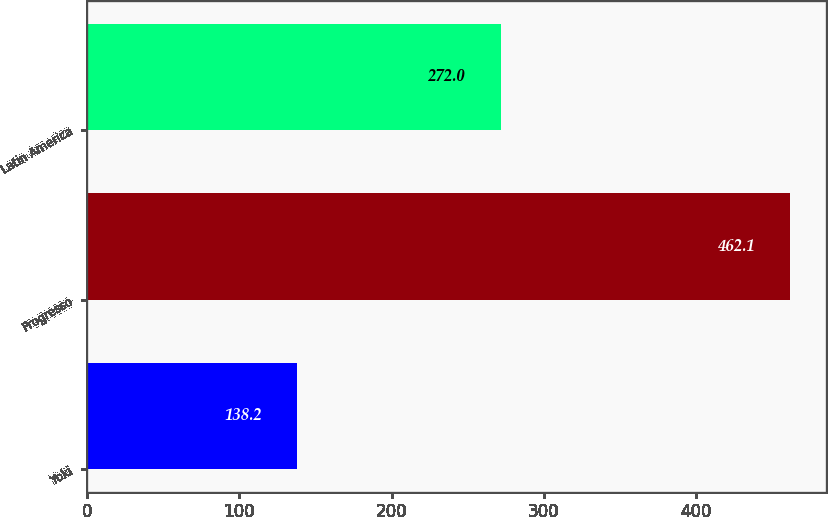<chart> <loc_0><loc_0><loc_500><loc_500><bar_chart><fcel>Yoki<fcel>Progresso<fcel>Latin America<nl><fcel>138.2<fcel>462.1<fcel>272<nl></chart> 